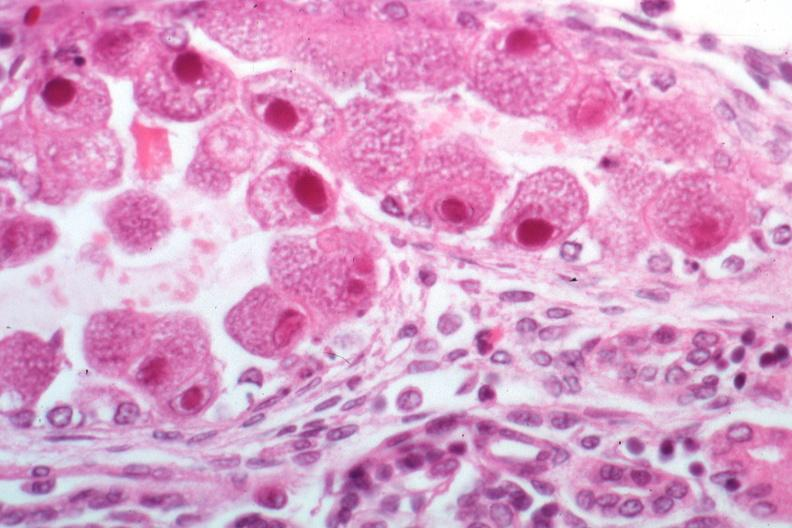s cytomegalovirus present?
Answer the question using a single word or phrase. Yes 